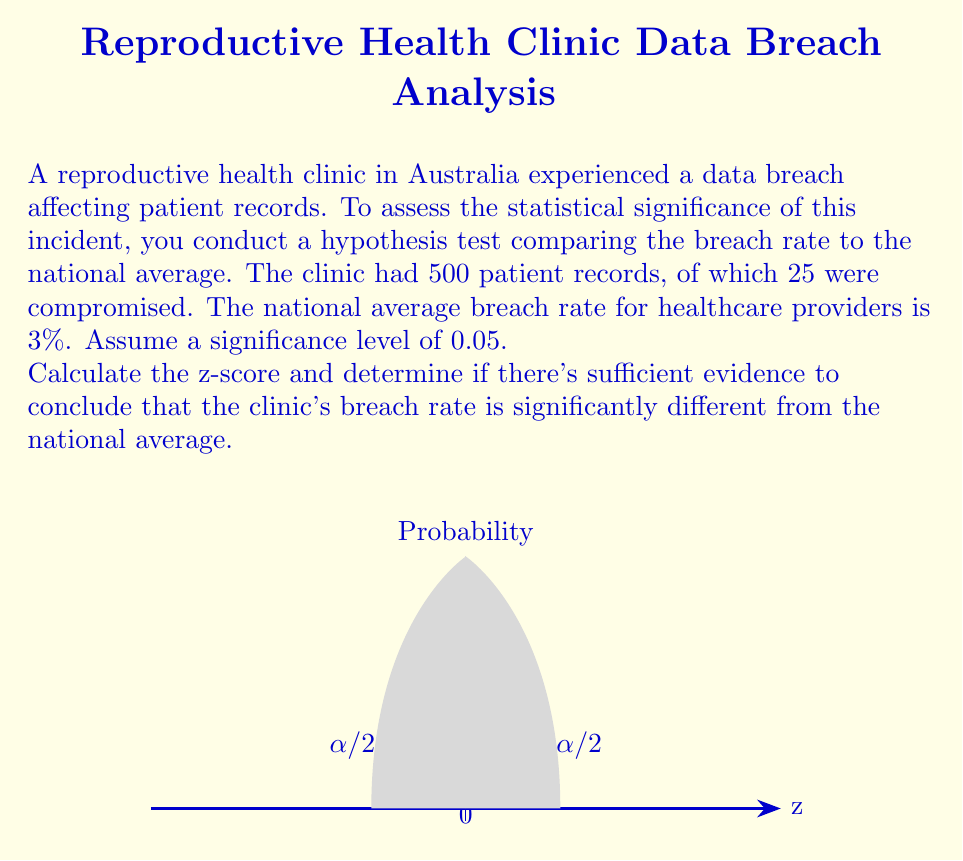Solve this math problem. To determine if the clinic's breach rate is significantly different from the national average, we'll follow these steps:

1) First, let's identify our variables:
   $n = 500$ (sample size)
   $x = 25$ (number of breaches)
   $p_0 = 0.03$ (national average breach rate)
   $\alpha = 0.05$ (significance level)

2) Calculate the sample proportion:
   $\hat{p} = \frac{x}{n} = \frac{25}{500} = 0.05$

3) Calculate the standard error:
   $SE = \sqrt{\frac{p_0(1-p_0)}{n}} = \sqrt{\frac{0.03(1-0.03)}{500}} \approx 0.00764$

4) Calculate the z-score:
   $z = \frac{\hat{p} - p_0}{SE} = \frac{0.05 - 0.03}{0.00764} \approx 2.62$

5) Determine the critical value:
   For a two-tailed test at $\alpha = 0.05$, the critical z-value is $\pm 1.96$

6) Compare the calculated z-score to the critical value:
   $|2.62| > 1.96$

7) Make a decision:
   Since the absolute value of our calculated z-score (2.62) is greater than the critical value (1.96), we reject the null hypothesis.
Answer: $z \approx 2.62$; Statistically significant difference 